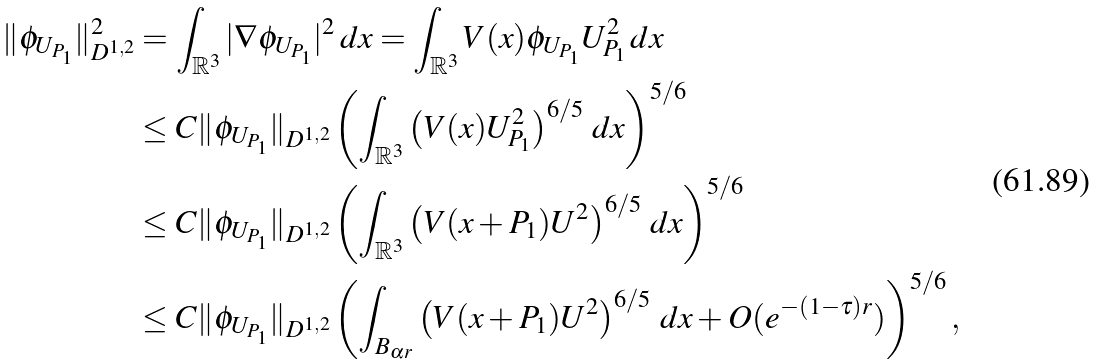<formula> <loc_0><loc_0><loc_500><loc_500>\| \phi _ { U _ { P _ { 1 } } } \| _ { D ^ { 1 , 2 } } ^ { 2 } & = \int _ { \mathbb { R } ^ { 3 } } | \nabla \phi _ { U _ { P _ { 1 } } } | ^ { 2 } \, d x = \int _ { \mathbb { R } ^ { 3 } } V ( x ) \phi _ { U _ { P _ { 1 } } } U _ { P _ { 1 } } ^ { 2 } \, d x \\ & \leq C \| \phi _ { U _ { P _ { 1 } } } \| _ { D ^ { 1 , 2 } } \left ( \int _ { \mathbb { R } ^ { 3 } } \left ( V ( x ) U _ { P _ { 1 } } ^ { 2 } \right ) ^ { 6 / 5 } \, d x \right ) ^ { 5 / 6 } \\ & \leq C \| \phi _ { U _ { P _ { 1 } } } \| _ { D ^ { 1 , 2 } } \left ( \int _ { \mathbb { R } ^ { 3 } } \left ( V ( x + P _ { 1 } ) U ^ { 2 } \right ) ^ { 6 / 5 } \, d x \right ) ^ { 5 / 6 } \\ & \leq C \| \phi _ { U _ { P _ { 1 } } } \| _ { D ^ { 1 , 2 } } \left ( \int _ { B _ { \alpha r } } \left ( V ( x + P _ { 1 } ) U ^ { 2 } \right ) ^ { 6 / 5 } \, d x + O ( e ^ { - ( 1 - \tau ) r } ) \right ) ^ { 5 / 6 } ,</formula> 